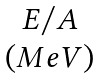<formula> <loc_0><loc_0><loc_500><loc_500>\begin{matrix} E / A \\ ( M e V ) \end{matrix}</formula> 